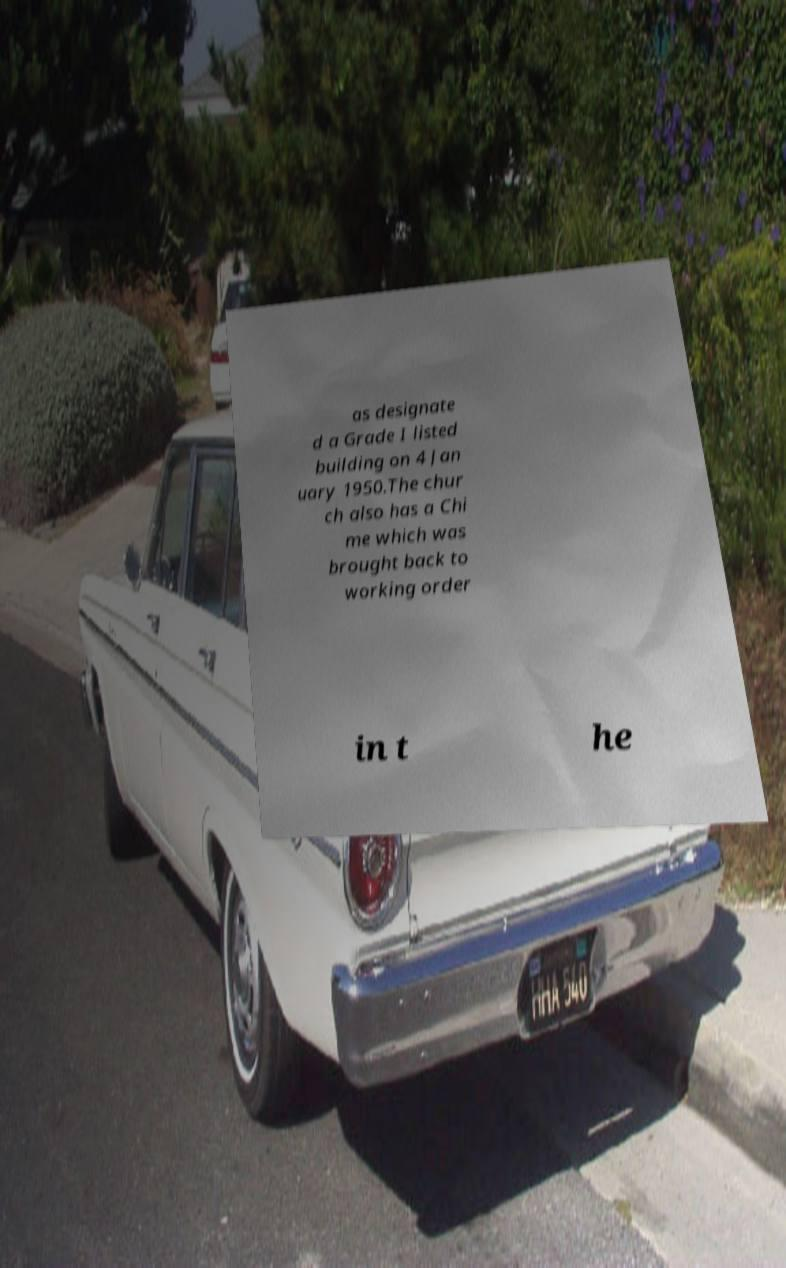Can you accurately transcribe the text from the provided image for me? as designate d a Grade I listed building on 4 Jan uary 1950.The chur ch also has a Chi me which was brought back to working order in t he 